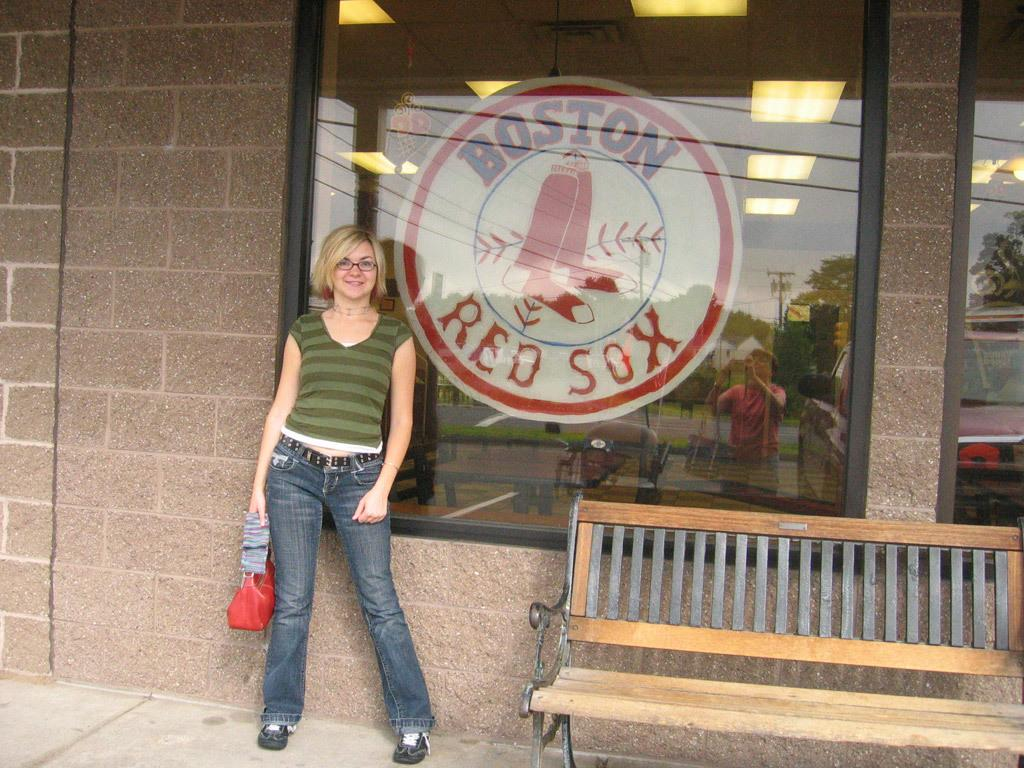What type of furniture is located on the right side of the image? There is a bench on the right side of the image. What is the person on the left side of the image doing? There is a person standing on the left side of the image. What can be seen in the background of the image? There is a building visible in the background of the image. What sports team is associated with the words written on the glass surface in the image? The words "Boston Red Sox" are written on a glass surface in the image, which is associated with the baseball team. How many islands can be seen in the image? There are no islands present in the image. What type of bath is visible in the image? There is no bath present in the image. 